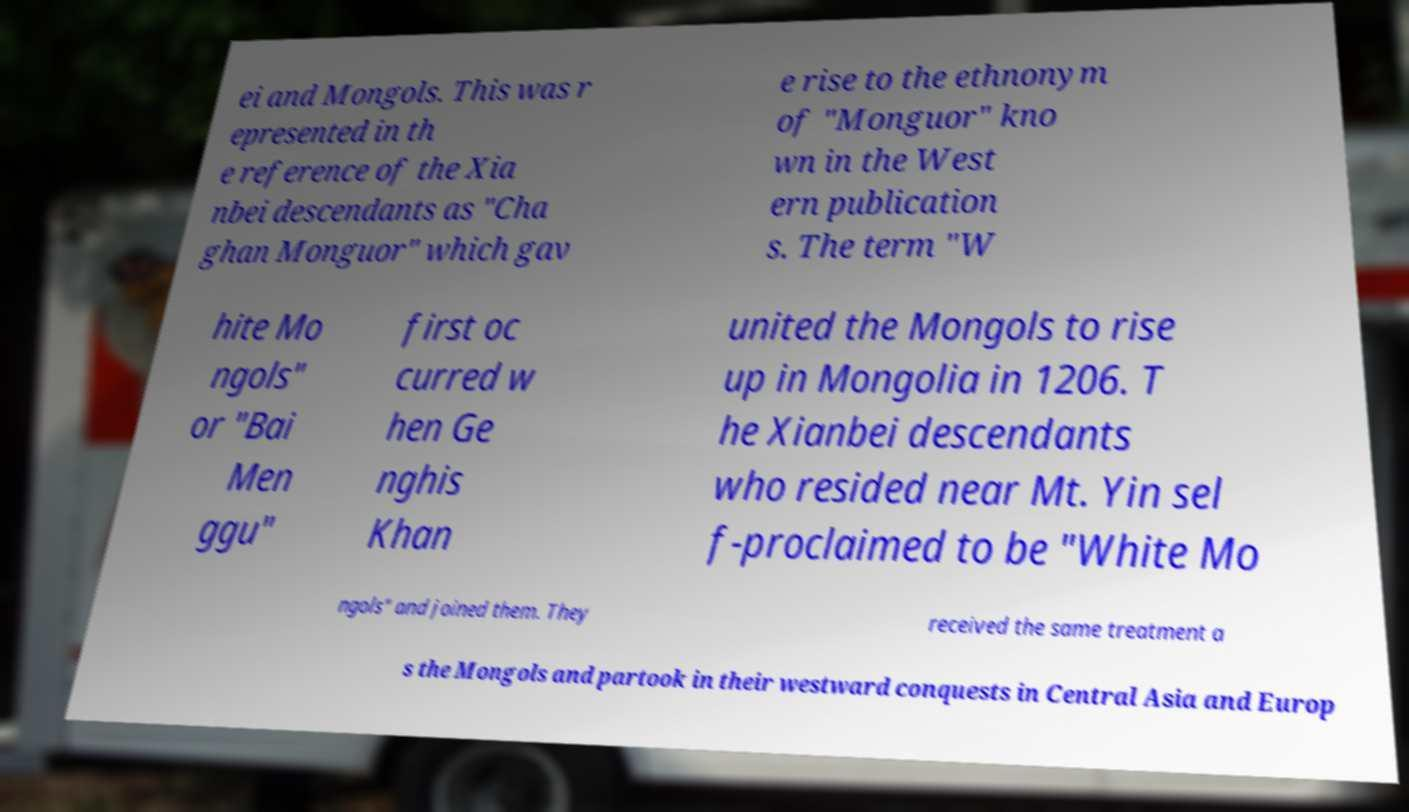Can you accurately transcribe the text from the provided image for me? ei and Mongols. This was r epresented in th e reference of the Xia nbei descendants as "Cha ghan Monguor" which gav e rise to the ethnonym of "Monguor" kno wn in the West ern publication s. The term "W hite Mo ngols" or "Bai Men ggu" first oc curred w hen Ge nghis Khan united the Mongols to rise up in Mongolia in 1206. T he Xianbei descendants who resided near Mt. Yin sel f-proclaimed to be "White Mo ngols" and joined them. They received the same treatment a s the Mongols and partook in their westward conquests in Central Asia and Europ 